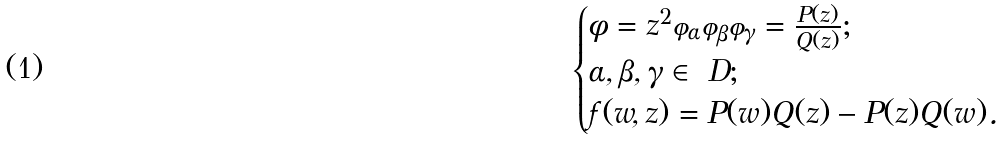Convert formula to latex. <formula><loc_0><loc_0><loc_500><loc_500>\begin{cases} \phi = z ^ { 2 } \varphi _ { \alpha } \varphi _ { \beta } \varphi _ { \gamma } = \frac { P ( z ) } { Q ( z ) } ; \\ \alpha , \beta , \gamma \in \ D ; \\ f ( w , z ) = P ( w ) Q ( z ) - P ( z ) Q ( w ) . \end{cases}</formula> 